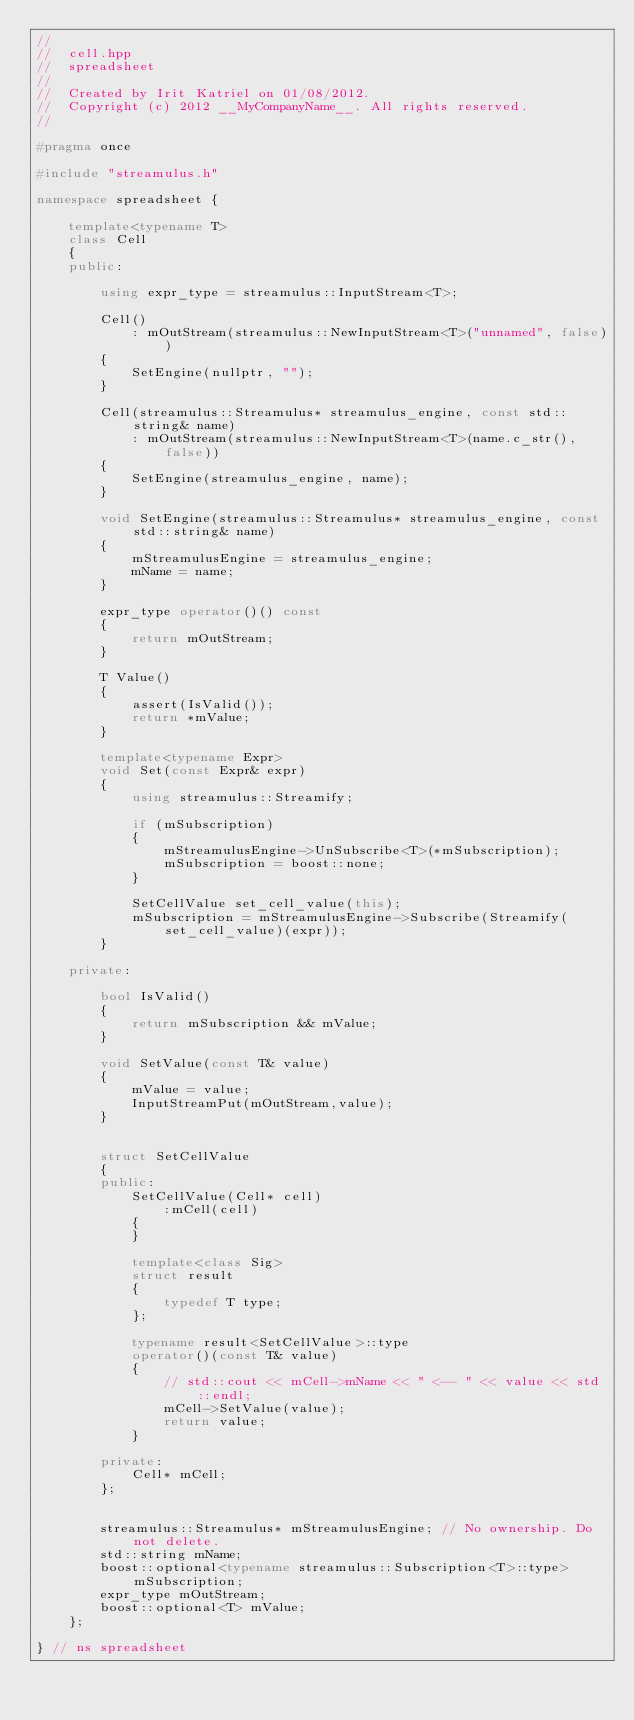Convert code to text. <code><loc_0><loc_0><loc_500><loc_500><_C++_>//
//  cell.hpp
//  spreadsheet
//
//  Created by Irit Katriel on 01/08/2012.
//  Copyright (c) 2012 __MyCompanyName__. All rights reserved.
//

#pragma once

#include "streamulus.h"

namespace spreadsheet {
    
    template<typename T>
    class Cell
    {
    public:
        
        using expr_type = streamulus::InputStream<T>;

        Cell()
            : mOutStream(streamulus::NewInputStream<T>("unnamed", false))
        {
            SetEngine(nullptr, "");
        }
        
        Cell(streamulus::Streamulus* streamulus_engine, const std::string& name)
            : mOutStream(streamulus::NewInputStream<T>(name.c_str(), false))
        {
            SetEngine(streamulus_engine, name);
        }
        
        void SetEngine(streamulus::Streamulus* streamulus_engine, const std::string& name)
        {
            mStreamulusEngine = streamulus_engine;
            mName = name;
        }
                
        expr_type operator()() const
        {
            return mOutStream;
        }
                
        T Value()
        {
            assert(IsValid());
            return *mValue;
        }
        
        template<typename Expr>
        void Set(const Expr& expr)
        {
            using streamulus::Streamify;
            
            if (mSubscription)
            {
                mStreamulusEngine->UnSubscribe<T>(*mSubscription);
                mSubscription = boost::none;
            }
            
            SetCellValue set_cell_value(this);
            mSubscription = mStreamulusEngine->Subscribe(Streamify(set_cell_value)(expr)); 
        }

    private:
                
        bool IsValid()
        {
            return mSubscription && mValue;
        }
        
        void SetValue(const T& value)
        {
            mValue = value;
            InputStreamPut(mOutStream,value);
        }
        
        
        struct SetCellValue
        {
        public:
            SetCellValue(Cell* cell)
                :mCell(cell)
            {
            }
            
            template<class Sig> 
            struct result 
            {
                typedef T type; 
            };
            
            typename result<SetCellValue>::type
            operator()(const T& value)
            {
                // std::cout << mCell->mName << " <-- " << value << std::endl;
                mCell->SetValue(value);
                return value;
            }
            
        private:
            Cell* mCell;
        };
        

        streamulus::Streamulus* mStreamulusEngine; // No ownership. Do not delete.
        std::string mName;
        boost::optional<typename streamulus::Subscription<T>::type> mSubscription;
        expr_type mOutStream;
        boost::optional<T> mValue;
    };
    
} // ns spreadsheet


</code> 